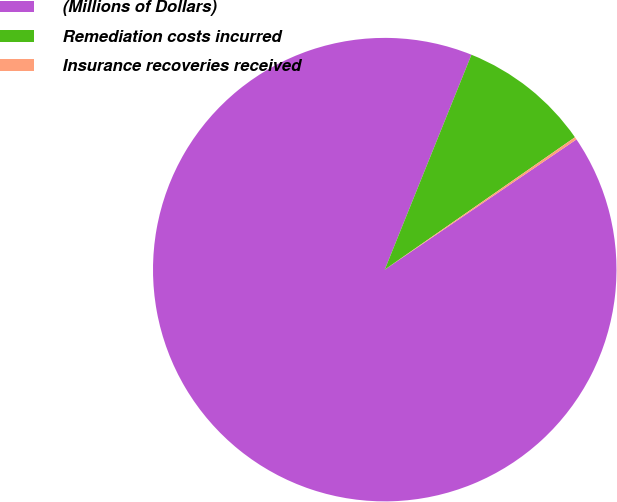Convert chart. <chart><loc_0><loc_0><loc_500><loc_500><pie_chart><fcel>(Millions of Dollars)<fcel>Remediation costs incurred<fcel>Insurance recoveries received<nl><fcel>90.6%<fcel>9.22%<fcel>0.18%<nl></chart> 